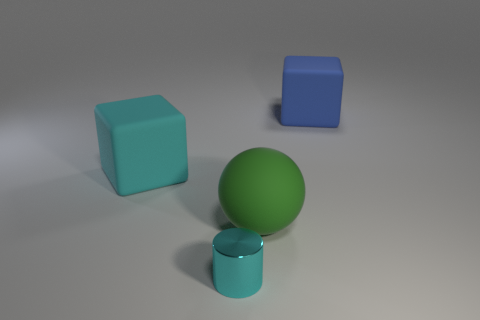Add 2 large brown metallic objects. How many objects exist? 6 Subtract all cylinders. How many objects are left? 3 Add 4 blue cubes. How many blue cubes exist? 5 Subtract 1 green spheres. How many objects are left? 3 Subtract all big yellow rubber blocks. Subtract all green rubber things. How many objects are left? 3 Add 3 big rubber balls. How many big rubber balls are left? 4 